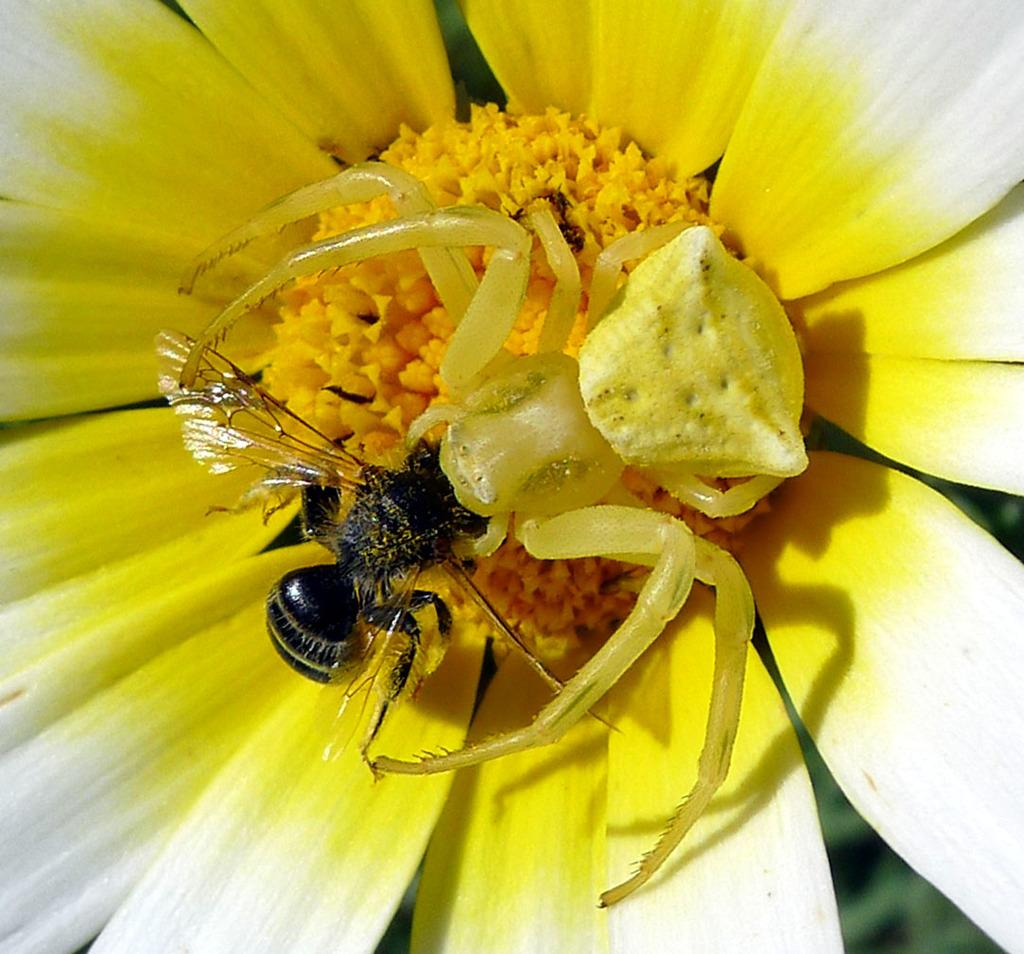What insects can be seen in the image? There is a spider and a bee in the image. Where are the spider and bee located in the image? The spider and bee are on a flower. Can you describe the flower in the image? The flower has white petals and yellow petals. What type of sofa can be seen in the image? There is no sofa present in the image. What angle is the hat tilted at in the image? There is no hat present in the image. 